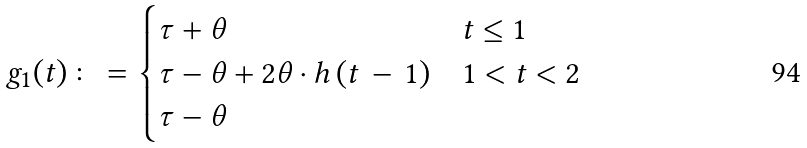<formula> <loc_0><loc_0><loc_500><loc_500>g _ { 1 } ( t ) & \colon = \begin{cases} \tau + \theta & t \leq 1 \\ \tau - \theta + 2 \theta \cdot h \left ( t \, - \, 1 \right ) & 1 < t < 2 \\ \tau - \theta & \end{cases}</formula> 